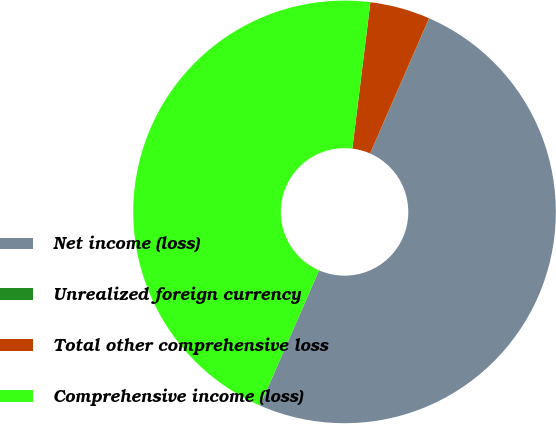Convert chart to OTSL. <chart><loc_0><loc_0><loc_500><loc_500><pie_chart><fcel>Net income (loss)<fcel>Unrealized foreign currency<fcel>Total other comprehensive loss<fcel>Comprehensive income (loss)<nl><fcel>49.98%<fcel>0.02%<fcel>4.6%<fcel>45.4%<nl></chart> 